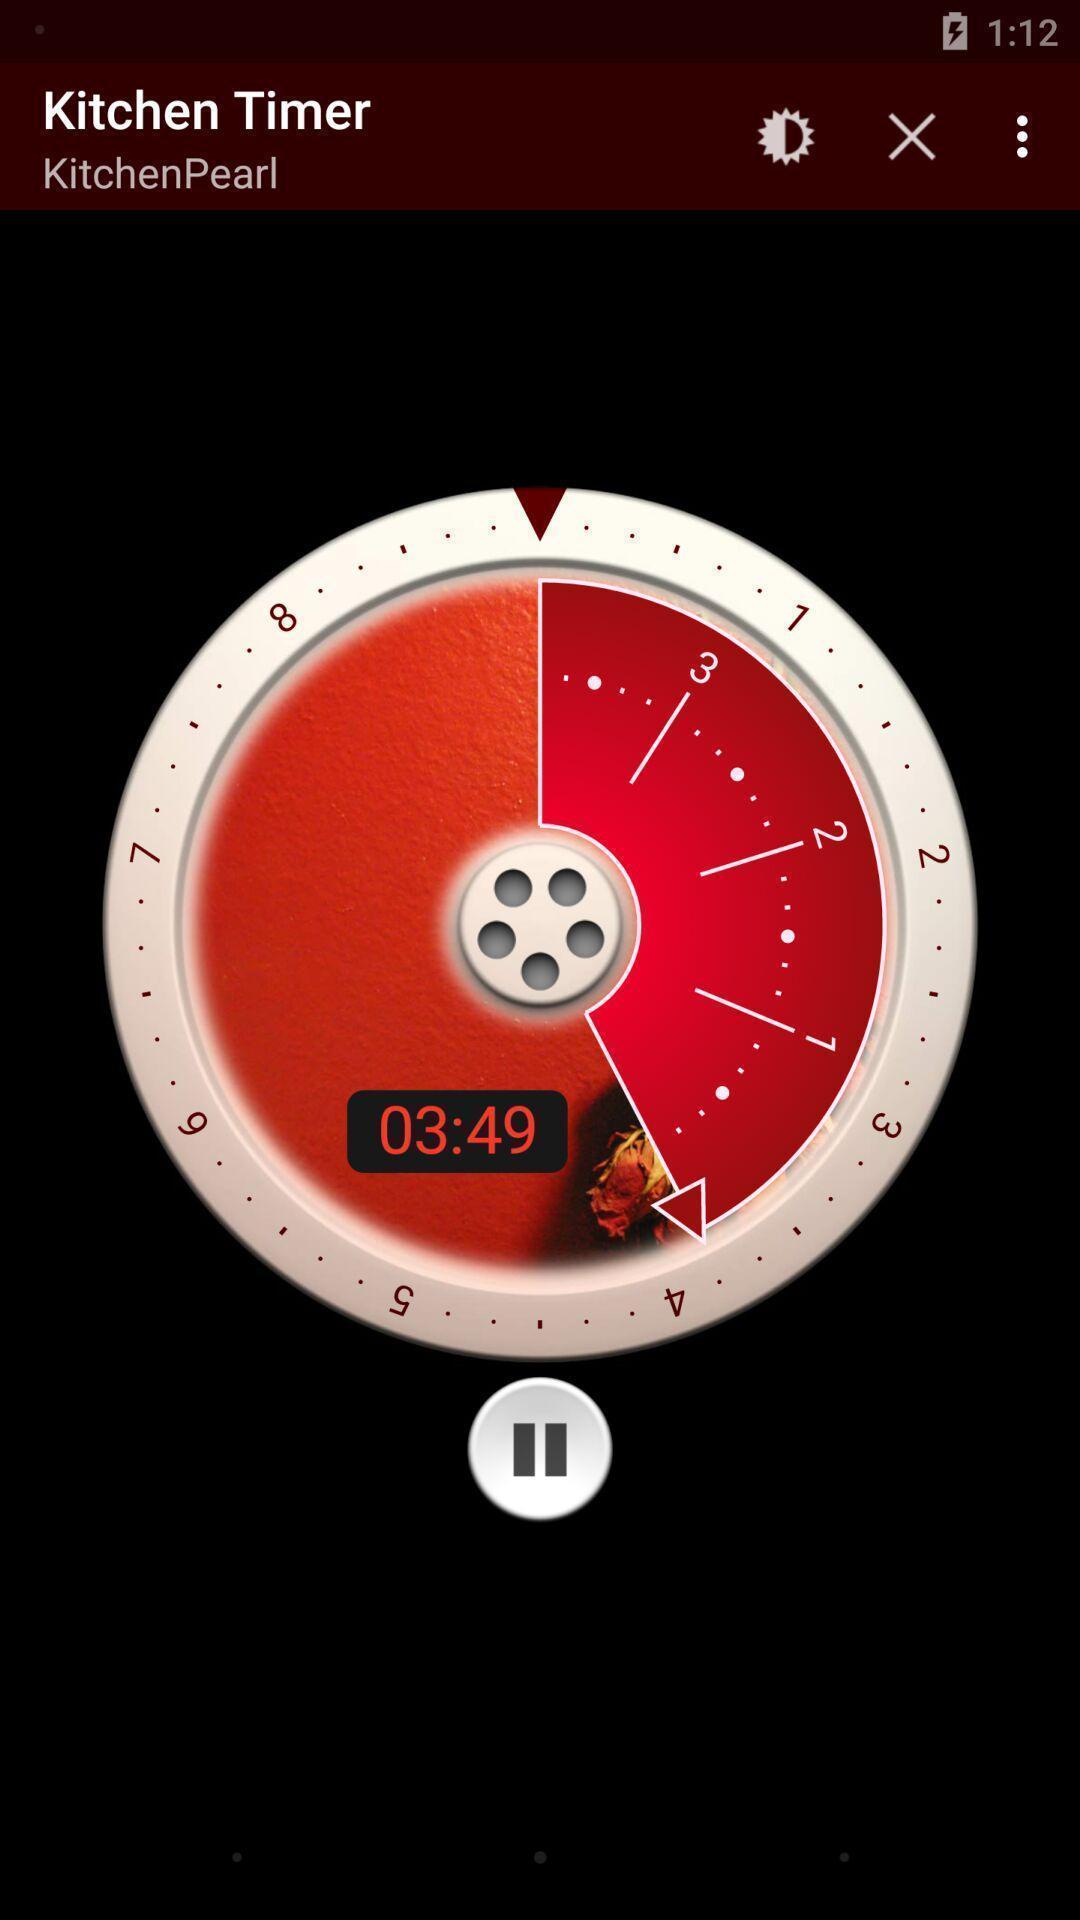Give me a summary of this screen capture. Timer with pause button. 